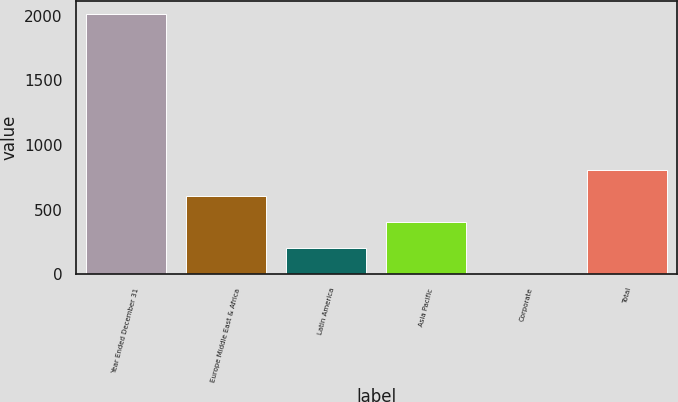Convert chart. <chart><loc_0><loc_0><loc_500><loc_500><bar_chart><fcel>Year Ended December 31<fcel>Europe Middle East & Africa<fcel>Latin America<fcel>Asia Pacific<fcel>Corporate<fcel>Total<nl><fcel>2017<fcel>605.38<fcel>202.06<fcel>403.72<fcel>0.4<fcel>807.04<nl></chart> 